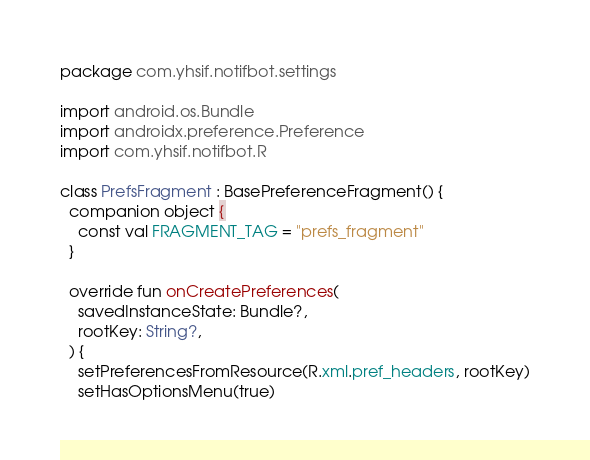Convert code to text. <code><loc_0><loc_0><loc_500><loc_500><_Kotlin_>package com.yhsif.notifbot.settings

import android.os.Bundle
import androidx.preference.Preference
import com.yhsif.notifbot.R

class PrefsFragment : BasePreferenceFragment() {
  companion object {
    const val FRAGMENT_TAG = "prefs_fragment"
  }

  override fun onCreatePreferences(
    savedInstanceState: Bundle?,
    rootKey: String?,
  ) {
    setPreferencesFromResource(R.xml.pref_headers, rootKey)
    setHasOptionsMenu(true)
</code> 